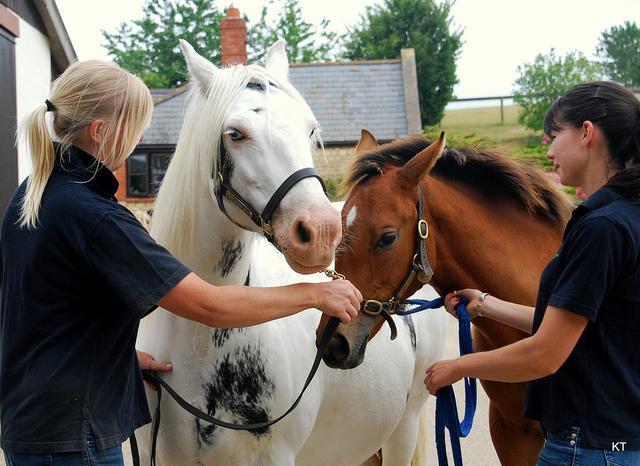How many ponytails are visible in the picture?
Give a very brief answer. 1. How many horses are there?
Give a very brief answer. 2. How many people are in the picture?
Give a very brief answer. 2. 